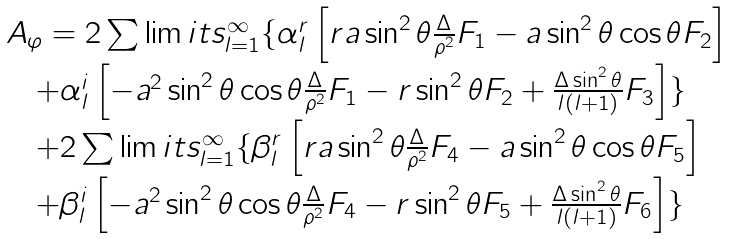Convert formula to latex. <formula><loc_0><loc_0><loc_500><loc_500>\begin{array} { l } A _ { \varphi } = 2 \sum \lim i t s _ { l = 1 } ^ { \infty } \{ { { \alpha _ { l } ^ { r } \left [ { r a \sin ^ { 2 } \theta \frac { \Delta } { \rho ^ { 2 } } F _ { 1 } - a \sin ^ { 2 } \theta \cos \theta F _ { 2 } } \right ] } } \\ \quad + \alpha _ { l } ^ { i } \left [ - a ^ { 2 } \sin ^ { 2 } \theta \cos \theta \frac { \Delta } { \rho ^ { 2 } } F _ { 1 } - r \sin ^ { 2 } \theta F _ { 2 } + \frac { \Delta \sin ^ { 2 } \theta } { l \left ( { l + 1 } \right ) } F _ { 3 } \right ] \} \\ \quad + 2 \sum \lim i t s _ { l = 1 } ^ { \infty } \{ { { \beta _ { l } ^ { r } \left [ { r a \sin ^ { 2 } \theta \frac { \Delta } { \rho ^ { 2 } } F _ { 4 } - a \sin ^ { 2 } \theta \cos \theta F _ { 5 } } \right ] } } \\ \quad + \beta _ { l } ^ { i } \left [ { - a ^ { 2 } \sin ^ { 2 } \theta \cos \theta \frac { \Delta } { \rho ^ { 2 } } F _ { 4 } } - r \sin ^ { 2 } \theta F _ { 5 } + \frac { \Delta \sin ^ { 2 } \theta } { l \left ( { l + 1 } \right ) } F _ { 6 } \right ] \} \end{array}</formula> 